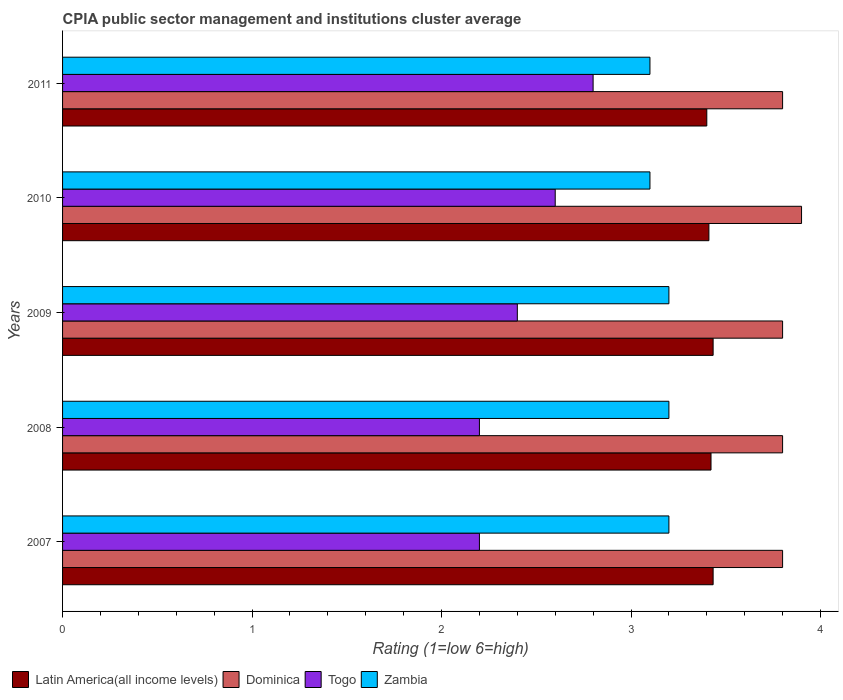How many groups of bars are there?
Your answer should be very brief. 5. Are the number of bars per tick equal to the number of legend labels?
Your answer should be compact. Yes. Are the number of bars on each tick of the Y-axis equal?
Offer a very short reply. Yes. How many bars are there on the 2nd tick from the bottom?
Make the answer very short. 4. Across all years, what is the minimum CPIA rating in Togo?
Offer a terse response. 2.2. In which year was the CPIA rating in Zambia minimum?
Provide a succinct answer. 2010. What is the difference between the CPIA rating in Togo in 2007 and that in 2009?
Offer a terse response. -0.2. What is the difference between the CPIA rating in Dominica in 2009 and the CPIA rating in Zambia in 2007?
Your answer should be compact. 0.6. What is the average CPIA rating in Dominica per year?
Provide a succinct answer. 3.82. In the year 2011, what is the difference between the CPIA rating in Togo and CPIA rating in Latin America(all income levels)?
Make the answer very short. -0.6. In how many years, is the CPIA rating in Dominica greater than 3.2 ?
Give a very brief answer. 5. What is the ratio of the CPIA rating in Zambia in 2008 to that in 2009?
Provide a short and direct response. 1. Is the difference between the CPIA rating in Togo in 2008 and 2011 greater than the difference between the CPIA rating in Latin America(all income levels) in 2008 and 2011?
Your answer should be compact. No. What is the difference between the highest and the second highest CPIA rating in Togo?
Provide a short and direct response. 0.2. What is the difference between the highest and the lowest CPIA rating in Dominica?
Make the answer very short. 0.1. Is the sum of the CPIA rating in Dominica in 2008 and 2011 greater than the maximum CPIA rating in Latin America(all income levels) across all years?
Offer a very short reply. Yes. What does the 2nd bar from the top in 2008 represents?
Your response must be concise. Togo. What does the 4th bar from the bottom in 2007 represents?
Make the answer very short. Zambia. How many years are there in the graph?
Your answer should be compact. 5. What is the difference between two consecutive major ticks on the X-axis?
Your response must be concise. 1. Are the values on the major ticks of X-axis written in scientific E-notation?
Your answer should be very brief. No. Does the graph contain any zero values?
Keep it short and to the point. No. How many legend labels are there?
Your answer should be very brief. 4. What is the title of the graph?
Provide a short and direct response. CPIA public sector management and institutions cluster average. Does "Europe(developing only)" appear as one of the legend labels in the graph?
Provide a succinct answer. No. What is the label or title of the Y-axis?
Offer a very short reply. Years. What is the Rating (1=low 6=high) of Latin America(all income levels) in 2007?
Your answer should be compact. 3.43. What is the Rating (1=low 6=high) in Dominica in 2007?
Make the answer very short. 3.8. What is the Rating (1=low 6=high) in Latin America(all income levels) in 2008?
Your answer should be very brief. 3.42. What is the Rating (1=low 6=high) in Latin America(all income levels) in 2009?
Your response must be concise. 3.43. What is the Rating (1=low 6=high) in Zambia in 2009?
Make the answer very short. 3.2. What is the Rating (1=low 6=high) in Latin America(all income levels) in 2010?
Offer a very short reply. 3.41. What is the Rating (1=low 6=high) in Togo in 2010?
Your answer should be very brief. 2.6. What is the Rating (1=low 6=high) in Latin America(all income levels) in 2011?
Provide a short and direct response. 3.4. What is the Rating (1=low 6=high) in Dominica in 2011?
Offer a terse response. 3.8. What is the Rating (1=low 6=high) in Zambia in 2011?
Provide a short and direct response. 3.1. Across all years, what is the maximum Rating (1=low 6=high) of Latin America(all income levels)?
Give a very brief answer. 3.43. Across all years, what is the maximum Rating (1=low 6=high) in Dominica?
Provide a short and direct response. 3.9. Across all years, what is the maximum Rating (1=low 6=high) of Zambia?
Make the answer very short. 3.2. Across all years, what is the minimum Rating (1=low 6=high) of Latin America(all income levels)?
Keep it short and to the point. 3.4. Across all years, what is the minimum Rating (1=low 6=high) in Togo?
Your response must be concise. 2.2. What is the total Rating (1=low 6=high) of Dominica in the graph?
Give a very brief answer. 19.1. What is the total Rating (1=low 6=high) in Zambia in the graph?
Offer a very short reply. 15.8. What is the difference between the Rating (1=low 6=high) of Latin America(all income levels) in 2007 and that in 2008?
Your response must be concise. 0.01. What is the difference between the Rating (1=low 6=high) of Dominica in 2007 and that in 2008?
Keep it short and to the point. 0. What is the difference between the Rating (1=low 6=high) in Zambia in 2007 and that in 2008?
Your answer should be compact. 0. What is the difference between the Rating (1=low 6=high) in Latin America(all income levels) in 2007 and that in 2009?
Your answer should be compact. 0. What is the difference between the Rating (1=low 6=high) in Togo in 2007 and that in 2009?
Offer a very short reply. -0.2. What is the difference between the Rating (1=low 6=high) in Zambia in 2007 and that in 2009?
Keep it short and to the point. 0. What is the difference between the Rating (1=low 6=high) of Latin America(all income levels) in 2007 and that in 2010?
Ensure brevity in your answer.  0.02. What is the difference between the Rating (1=low 6=high) in Dominica in 2007 and that in 2010?
Provide a short and direct response. -0.1. What is the difference between the Rating (1=low 6=high) of Togo in 2007 and that in 2010?
Offer a very short reply. -0.4. What is the difference between the Rating (1=low 6=high) in Latin America(all income levels) in 2007 and that in 2011?
Provide a succinct answer. 0.03. What is the difference between the Rating (1=low 6=high) of Dominica in 2007 and that in 2011?
Keep it short and to the point. 0. What is the difference between the Rating (1=low 6=high) in Togo in 2007 and that in 2011?
Provide a short and direct response. -0.6. What is the difference between the Rating (1=low 6=high) in Zambia in 2007 and that in 2011?
Make the answer very short. 0.1. What is the difference between the Rating (1=low 6=high) of Latin America(all income levels) in 2008 and that in 2009?
Your response must be concise. -0.01. What is the difference between the Rating (1=low 6=high) in Dominica in 2008 and that in 2009?
Offer a very short reply. 0. What is the difference between the Rating (1=low 6=high) in Togo in 2008 and that in 2009?
Your answer should be compact. -0.2. What is the difference between the Rating (1=low 6=high) of Zambia in 2008 and that in 2009?
Offer a very short reply. 0. What is the difference between the Rating (1=low 6=high) of Latin America(all income levels) in 2008 and that in 2010?
Offer a terse response. 0.01. What is the difference between the Rating (1=low 6=high) of Zambia in 2008 and that in 2010?
Ensure brevity in your answer.  0.1. What is the difference between the Rating (1=low 6=high) in Latin America(all income levels) in 2008 and that in 2011?
Provide a succinct answer. 0.02. What is the difference between the Rating (1=low 6=high) in Togo in 2008 and that in 2011?
Ensure brevity in your answer.  -0.6. What is the difference between the Rating (1=low 6=high) of Zambia in 2008 and that in 2011?
Your answer should be very brief. 0.1. What is the difference between the Rating (1=low 6=high) in Latin America(all income levels) in 2009 and that in 2010?
Make the answer very short. 0.02. What is the difference between the Rating (1=low 6=high) of Togo in 2009 and that in 2010?
Provide a short and direct response. -0.2. What is the difference between the Rating (1=low 6=high) in Latin America(all income levels) in 2009 and that in 2011?
Your answer should be compact. 0.03. What is the difference between the Rating (1=low 6=high) in Togo in 2009 and that in 2011?
Give a very brief answer. -0.4. What is the difference between the Rating (1=low 6=high) in Zambia in 2009 and that in 2011?
Provide a succinct answer. 0.1. What is the difference between the Rating (1=low 6=high) of Latin America(all income levels) in 2010 and that in 2011?
Make the answer very short. 0.01. What is the difference between the Rating (1=low 6=high) of Dominica in 2010 and that in 2011?
Your response must be concise. 0.1. What is the difference between the Rating (1=low 6=high) of Latin America(all income levels) in 2007 and the Rating (1=low 6=high) of Dominica in 2008?
Your response must be concise. -0.37. What is the difference between the Rating (1=low 6=high) in Latin America(all income levels) in 2007 and the Rating (1=low 6=high) in Togo in 2008?
Make the answer very short. 1.23. What is the difference between the Rating (1=low 6=high) of Latin America(all income levels) in 2007 and the Rating (1=low 6=high) of Zambia in 2008?
Make the answer very short. 0.23. What is the difference between the Rating (1=low 6=high) in Dominica in 2007 and the Rating (1=low 6=high) in Zambia in 2008?
Ensure brevity in your answer.  0.6. What is the difference between the Rating (1=low 6=high) of Togo in 2007 and the Rating (1=low 6=high) of Zambia in 2008?
Give a very brief answer. -1. What is the difference between the Rating (1=low 6=high) in Latin America(all income levels) in 2007 and the Rating (1=low 6=high) in Dominica in 2009?
Your response must be concise. -0.37. What is the difference between the Rating (1=low 6=high) in Latin America(all income levels) in 2007 and the Rating (1=low 6=high) in Togo in 2009?
Make the answer very short. 1.03. What is the difference between the Rating (1=low 6=high) in Latin America(all income levels) in 2007 and the Rating (1=low 6=high) in Zambia in 2009?
Your answer should be compact. 0.23. What is the difference between the Rating (1=low 6=high) of Latin America(all income levels) in 2007 and the Rating (1=low 6=high) of Dominica in 2010?
Offer a terse response. -0.47. What is the difference between the Rating (1=low 6=high) in Dominica in 2007 and the Rating (1=low 6=high) in Togo in 2010?
Your answer should be compact. 1.2. What is the difference between the Rating (1=low 6=high) in Dominica in 2007 and the Rating (1=low 6=high) in Zambia in 2010?
Your answer should be compact. 0.7. What is the difference between the Rating (1=low 6=high) in Latin America(all income levels) in 2007 and the Rating (1=low 6=high) in Dominica in 2011?
Offer a terse response. -0.37. What is the difference between the Rating (1=low 6=high) in Latin America(all income levels) in 2007 and the Rating (1=low 6=high) in Togo in 2011?
Ensure brevity in your answer.  0.63. What is the difference between the Rating (1=low 6=high) of Dominica in 2007 and the Rating (1=low 6=high) of Zambia in 2011?
Your answer should be compact. 0.7. What is the difference between the Rating (1=low 6=high) in Togo in 2007 and the Rating (1=low 6=high) in Zambia in 2011?
Provide a short and direct response. -0.9. What is the difference between the Rating (1=low 6=high) in Latin America(all income levels) in 2008 and the Rating (1=low 6=high) in Dominica in 2009?
Provide a succinct answer. -0.38. What is the difference between the Rating (1=low 6=high) of Latin America(all income levels) in 2008 and the Rating (1=low 6=high) of Togo in 2009?
Keep it short and to the point. 1.02. What is the difference between the Rating (1=low 6=high) in Latin America(all income levels) in 2008 and the Rating (1=low 6=high) in Zambia in 2009?
Offer a terse response. 0.22. What is the difference between the Rating (1=low 6=high) in Dominica in 2008 and the Rating (1=low 6=high) in Zambia in 2009?
Offer a very short reply. 0.6. What is the difference between the Rating (1=low 6=high) of Togo in 2008 and the Rating (1=low 6=high) of Zambia in 2009?
Provide a succinct answer. -1. What is the difference between the Rating (1=low 6=high) in Latin America(all income levels) in 2008 and the Rating (1=low 6=high) in Dominica in 2010?
Make the answer very short. -0.48. What is the difference between the Rating (1=low 6=high) of Latin America(all income levels) in 2008 and the Rating (1=low 6=high) of Togo in 2010?
Your answer should be compact. 0.82. What is the difference between the Rating (1=low 6=high) in Latin America(all income levels) in 2008 and the Rating (1=low 6=high) in Zambia in 2010?
Offer a very short reply. 0.32. What is the difference between the Rating (1=low 6=high) in Dominica in 2008 and the Rating (1=low 6=high) in Togo in 2010?
Ensure brevity in your answer.  1.2. What is the difference between the Rating (1=low 6=high) in Dominica in 2008 and the Rating (1=low 6=high) in Zambia in 2010?
Make the answer very short. 0.7. What is the difference between the Rating (1=low 6=high) of Togo in 2008 and the Rating (1=low 6=high) of Zambia in 2010?
Keep it short and to the point. -0.9. What is the difference between the Rating (1=low 6=high) of Latin America(all income levels) in 2008 and the Rating (1=low 6=high) of Dominica in 2011?
Give a very brief answer. -0.38. What is the difference between the Rating (1=low 6=high) in Latin America(all income levels) in 2008 and the Rating (1=low 6=high) in Togo in 2011?
Your answer should be very brief. 0.62. What is the difference between the Rating (1=low 6=high) in Latin America(all income levels) in 2008 and the Rating (1=low 6=high) in Zambia in 2011?
Keep it short and to the point. 0.32. What is the difference between the Rating (1=low 6=high) in Dominica in 2008 and the Rating (1=low 6=high) in Zambia in 2011?
Your answer should be very brief. 0.7. What is the difference between the Rating (1=low 6=high) of Latin America(all income levels) in 2009 and the Rating (1=low 6=high) of Dominica in 2010?
Keep it short and to the point. -0.47. What is the difference between the Rating (1=low 6=high) in Latin America(all income levels) in 2009 and the Rating (1=low 6=high) in Zambia in 2010?
Your response must be concise. 0.33. What is the difference between the Rating (1=low 6=high) of Dominica in 2009 and the Rating (1=low 6=high) of Zambia in 2010?
Your answer should be compact. 0.7. What is the difference between the Rating (1=low 6=high) in Latin America(all income levels) in 2009 and the Rating (1=low 6=high) in Dominica in 2011?
Keep it short and to the point. -0.37. What is the difference between the Rating (1=low 6=high) of Latin America(all income levels) in 2009 and the Rating (1=low 6=high) of Togo in 2011?
Give a very brief answer. 0.63. What is the difference between the Rating (1=low 6=high) of Latin America(all income levels) in 2009 and the Rating (1=low 6=high) of Zambia in 2011?
Your answer should be very brief. 0.33. What is the difference between the Rating (1=low 6=high) in Dominica in 2009 and the Rating (1=low 6=high) in Zambia in 2011?
Make the answer very short. 0.7. What is the difference between the Rating (1=low 6=high) in Latin America(all income levels) in 2010 and the Rating (1=low 6=high) in Dominica in 2011?
Your response must be concise. -0.39. What is the difference between the Rating (1=low 6=high) in Latin America(all income levels) in 2010 and the Rating (1=low 6=high) in Togo in 2011?
Your answer should be compact. 0.61. What is the difference between the Rating (1=low 6=high) in Latin America(all income levels) in 2010 and the Rating (1=low 6=high) in Zambia in 2011?
Your response must be concise. 0.31. What is the average Rating (1=low 6=high) of Latin America(all income levels) per year?
Ensure brevity in your answer.  3.42. What is the average Rating (1=low 6=high) of Dominica per year?
Give a very brief answer. 3.82. What is the average Rating (1=low 6=high) in Togo per year?
Provide a short and direct response. 2.44. What is the average Rating (1=low 6=high) in Zambia per year?
Ensure brevity in your answer.  3.16. In the year 2007, what is the difference between the Rating (1=low 6=high) in Latin America(all income levels) and Rating (1=low 6=high) in Dominica?
Provide a short and direct response. -0.37. In the year 2007, what is the difference between the Rating (1=low 6=high) in Latin America(all income levels) and Rating (1=low 6=high) in Togo?
Your answer should be compact. 1.23. In the year 2007, what is the difference between the Rating (1=low 6=high) in Latin America(all income levels) and Rating (1=low 6=high) in Zambia?
Make the answer very short. 0.23. In the year 2007, what is the difference between the Rating (1=low 6=high) in Dominica and Rating (1=low 6=high) in Togo?
Provide a succinct answer. 1.6. In the year 2007, what is the difference between the Rating (1=low 6=high) of Dominica and Rating (1=low 6=high) of Zambia?
Offer a very short reply. 0.6. In the year 2008, what is the difference between the Rating (1=low 6=high) of Latin America(all income levels) and Rating (1=low 6=high) of Dominica?
Make the answer very short. -0.38. In the year 2008, what is the difference between the Rating (1=low 6=high) of Latin America(all income levels) and Rating (1=low 6=high) of Togo?
Keep it short and to the point. 1.22. In the year 2008, what is the difference between the Rating (1=low 6=high) in Latin America(all income levels) and Rating (1=low 6=high) in Zambia?
Give a very brief answer. 0.22. In the year 2008, what is the difference between the Rating (1=low 6=high) in Dominica and Rating (1=low 6=high) in Togo?
Keep it short and to the point. 1.6. In the year 2008, what is the difference between the Rating (1=low 6=high) in Dominica and Rating (1=low 6=high) in Zambia?
Your answer should be very brief. 0.6. In the year 2009, what is the difference between the Rating (1=low 6=high) in Latin America(all income levels) and Rating (1=low 6=high) in Dominica?
Keep it short and to the point. -0.37. In the year 2009, what is the difference between the Rating (1=low 6=high) in Latin America(all income levels) and Rating (1=low 6=high) in Zambia?
Make the answer very short. 0.23. In the year 2009, what is the difference between the Rating (1=low 6=high) of Dominica and Rating (1=low 6=high) of Zambia?
Your answer should be very brief. 0.6. In the year 2010, what is the difference between the Rating (1=low 6=high) of Latin America(all income levels) and Rating (1=low 6=high) of Dominica?
Offer a terse response. -0.49. In the year 2010, what is the difference between the Rating (1=low 6=high) in Latin America(all income levels) and Rating (1=low 6=high) in Togo?
Ensure brevity in your answer.  0.81. In the year 2010, what is the difference between the Rating (1=low 6=high) in Latin America(all income levels) and Rating (1=low 6=high) in Zambia?
Provide a short and direct response. 0.31. In the year 2010, what is the difference between the Rating (1=low 6=high) of Dominica and Rating (1=low 6=high) of Togo?
Offer a terse response. 1.3. In the year 2010, what is the difference between the Rating (1=low 6=high) in Dominica and Rating (1=low 6=high) in Zambia?
Your response must be concise. 0.8. In the year 2010, what is the difference between the Rating (1=low 6=high) of Togo and Rating (1=low 6=high) of Zambia?
Provide a short and direct response. -0.5. What is the ratio of the Rating (1=low 6=high) in Dominica in 2007 to that in 2008?
Your response must be concise. 1. What is the ratio of the Rating (1=low 6=high) in Togo in 2007 to that in 2008?
Provide a succinct answer. 1. What is the ratio of the Rating (1=low 6=high) in Latin America(all income levels) in 2007 to that in 2009?
Ensure brevity in your answer.  1. What is the ratio of the Rating (1=low 6=high) of Dominica in 2007 to that in 2009?
Your answer should be very brief. 1. What is the ratio of the Rating (1=low 6=high) in Latin America(all income levels) in 2007 to that in 2010?
Give a very brief answer. 1.01. What is the ratio of the Rating (1=low 6=high) in Dominica in 2007 to that in 2010?
Your answer should be very brief. 0.97. What is the ratio of the Rating (1=low 6=high) of Togo in 2007 to that in 2010?
Make the answer very short. 0.85. What is the ratio of the Rating (1=low 6=high) of Zambia in 2007 to that in 2010?
Provide a succinct answer. 1.03. What is the ratio of the Rating (1=low 6=high) of Latin America(all income levels) in 2007 to that in 2011?
Offer a terse response. 1.01. What is the ratio of the Rating (1=low 6=high) of Dominica in 2007 to that in 2011?
Make the answer very short. 1. What is the ratio of the Rating (1=low 6=high) in Togo in 2007 to that in 2011?
Offer a very short reply. 0.79. What is the ratio of the Rating (1=low 6=high) of Zambia in 2007 to that in 2011?
Provide a short and direct response. 1.03. What is the ratio of the Rating (1=low 6=high) of Latin America(all income levels) in 2008 to that in 2009?
Offer a terse response. 1. What is the ratio of the Rating (1=low 6=high) in Zambia in 2008 to that in 2009?
Your answer should be compact. 1. What is the ratio of the Rating (1=low 6=high) in Latin America(all income levels) in 2008 to that in 2010?
Make the answer very short. 1. What is the ratio of the Rating (1=low 6=high) in Dominica in 2008 to that in 2010?
Ensure brevity in your answer.  0.97. What is the ratio of the Rating (1=low 6=high) in Togo in 2008 to that in 2010?
Ensure brevity in your answer.  0.85. What is the ratio of the Rating (1=low 6=high) of Zambia in 2008 to that in 2010?
Ensure brevity in your answer.  1.03. What is the ratio of the Rating (1=low 6=high) in Latin America(all income levels) in 2008 to that in 2011?
Ensure brevity in your answer.  1.01. What is the ratio of the Rating (1=low 6=high) of Togo in 2008 to that in 2011?
Offer a very short reply. 0.79. What is the ratio of the Rating (1=low 6=high) of Zambia in 2008 to that in 2011?
Keep it short and to the point. 1.03. What is the ratio of the Rating (1=low 6=high) in Latin America(all income levels) in 2009 to that in 2010?
Your answer should be very brief. 1.01. What is the ratio of the Rating (1=low 6=high) of Dominica in 2009 to that in 2010?
Ensure brevity in your answer.  0.97. What is the ratio of the Rating (1=low 6=high) of Zambia in 2009 to that in 2010?
Offer a terse response. 1.03. What is the ratio of the Rating (1=low 6=high) of Latin America(all income levels) in 2009 to that in 2011?
Ensure brevity in your answer.  1.01. What is the ratio of the Rating (1=low 6=high) of Dominica in 2009 to that in 2011?
Your response must be concise. 1. What is the ratio of the Rating (1=low 6=high) in Togo in 2009 to that in 2011?
Ensure brevity in your answer.  0.86. What is the ratio of the Rating (1=low 6=high) in Zambia in 2009 to that in 2011?
Give a very brief answer. 1.03. What is the ratio of the Rating (1=low 6=high) in Dominica in 2010 to that in 2011?
Your answer should be compact. 1.03. What is the ratio of the Rating (1=low 6=high) in Togo in 2010 to that in 2011?
Ensure brevity in your answer.  0.93. What is the ratio of the Rating (1=low 6=high) in Zambia in 2010 to that in 2011?
Offer a terse response. 1. What is the difference between the highest and the second highest Rating (1=low 6=high) of Dominica?
Your response must be concise. 0.1. What is the difference between the highest and the second highest Rating (1=low 6=high) in Togo?
Your answer should be compact. 0.2. What is the difference between the highest and the lowest Rating (1=low 6=high) in Latin America(all income levels)?
Ensure brevity in your answer.  0.03. What is the difference between the highest and the lowest Rating (1=low 6=high) in Zambia?
Your answer should be very brief. 0.1. 